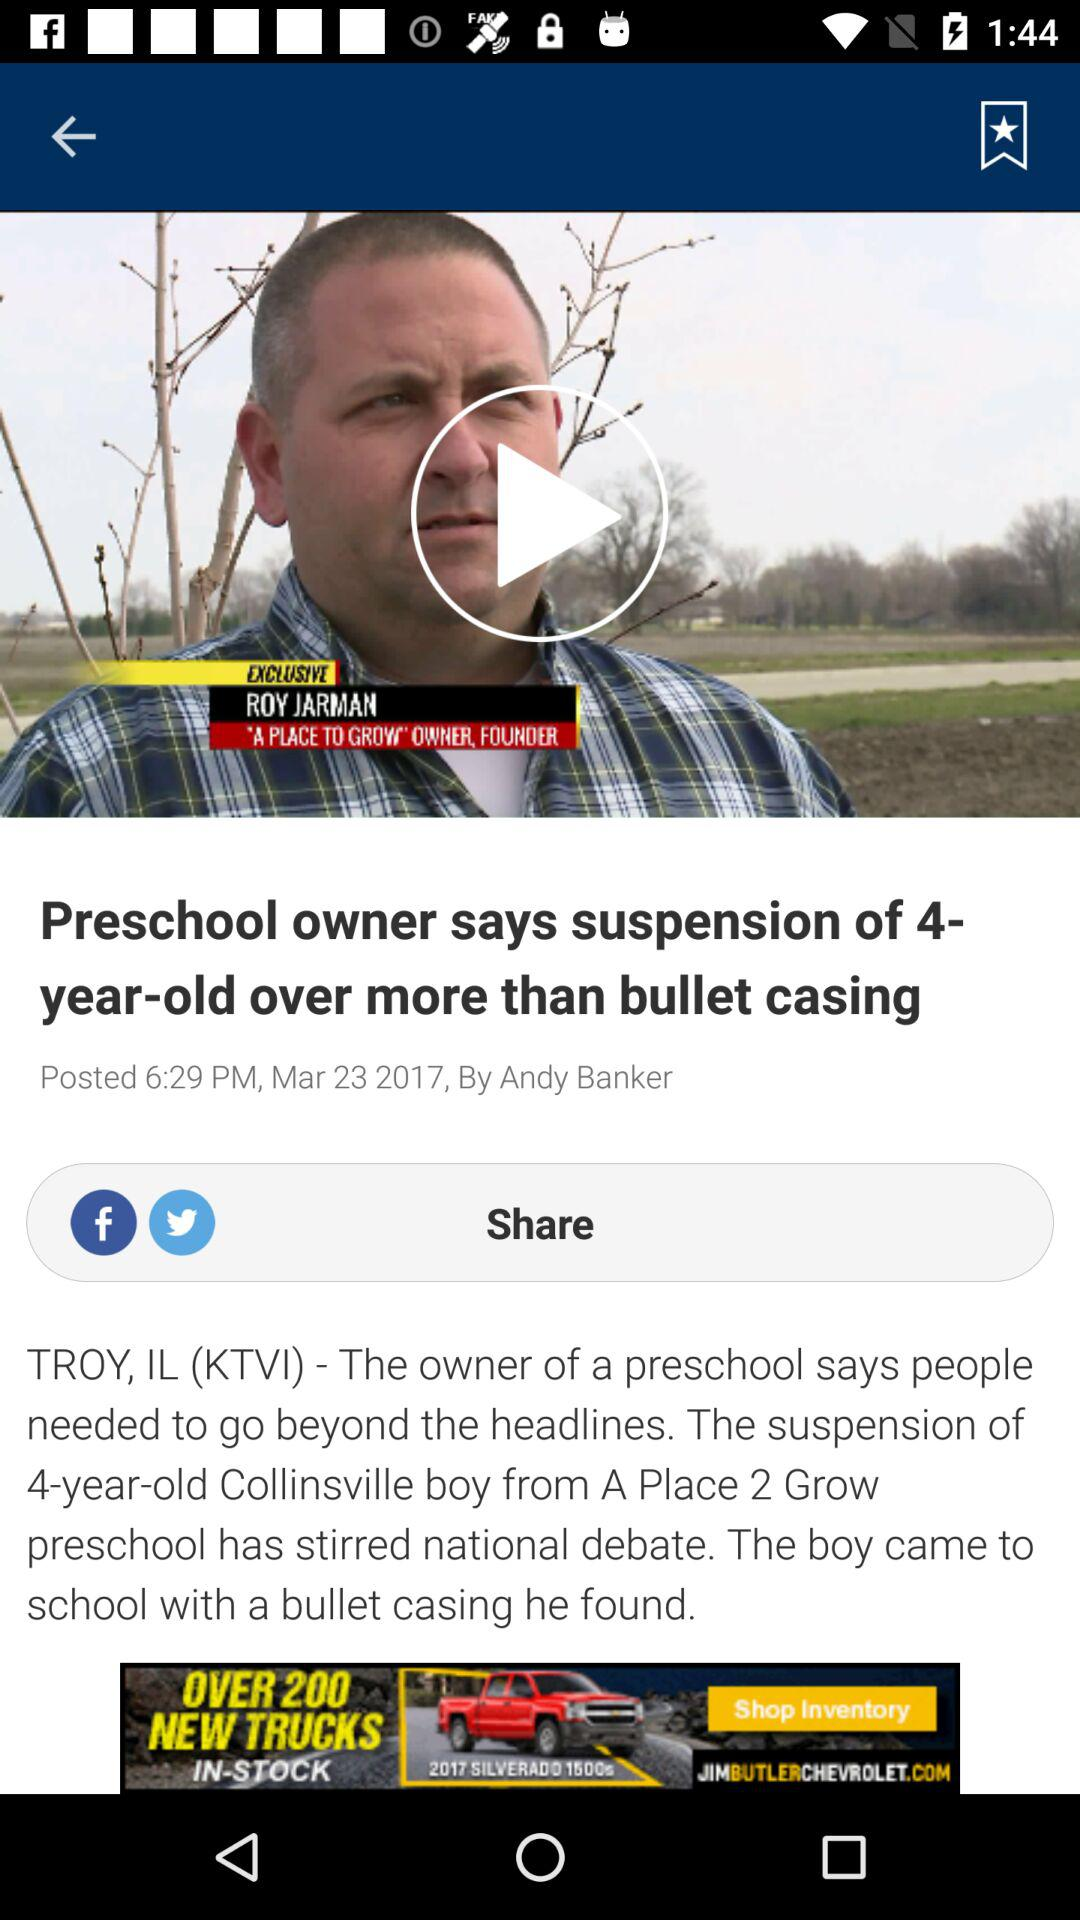Who's the founder and owner of "A PLACE TO GROW"? The founder and owner of "A PLACE TO GROW" is Roy Jarman. 